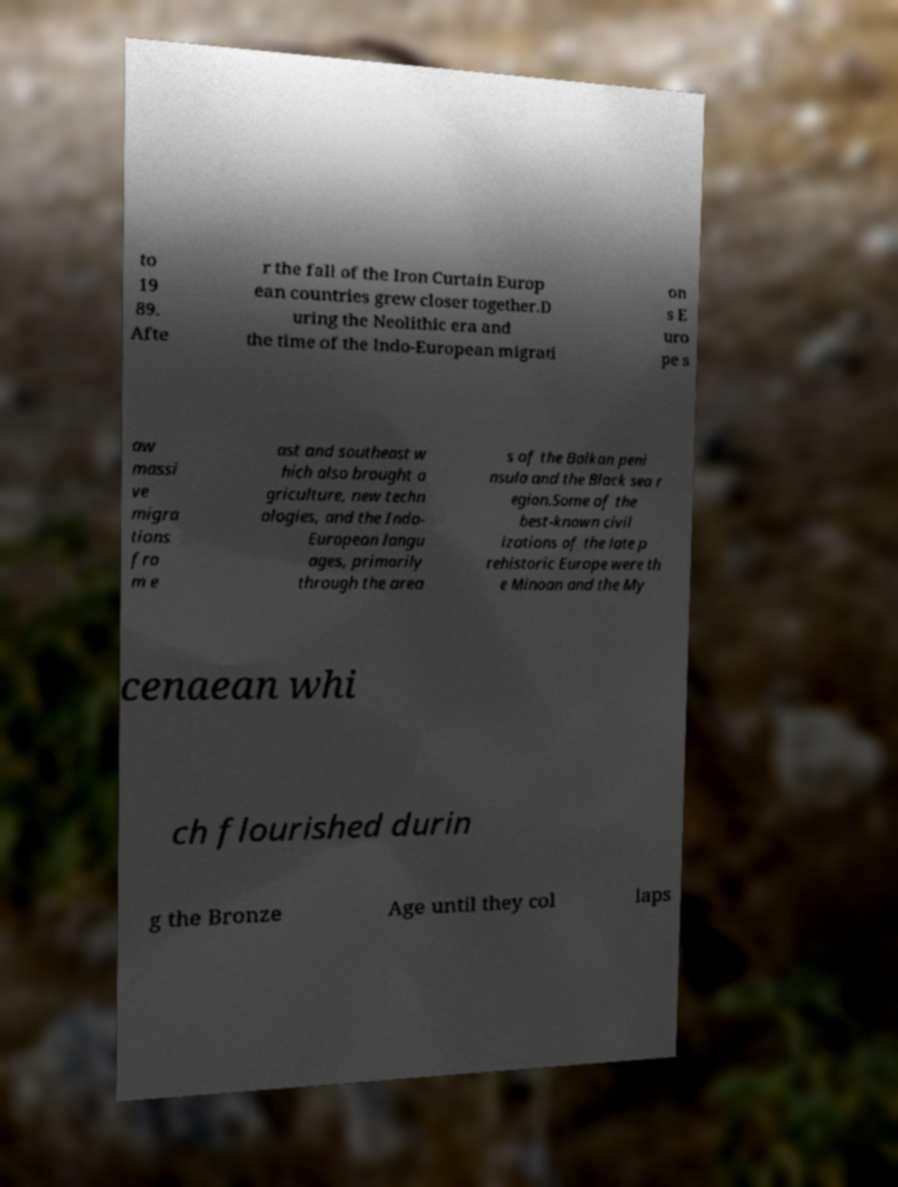Please identify and transcribe the text found in this image. to 19 89. Afte r the fall of the Iron Curtain Europ ean countries grew closer together.D uring the Neolithic era and the time of the Indo-European migrati on s E uro pe s aw massi ve migra tions fro m e ast and southeast w hich also brought a griculture, new techn ologies, and the Indo- European langu ages, primarily through the area s of the Balkan peni nsula and the Black sea r egion.Some of the best-known civil izations of the late p rehistoric Europe were th e Minoan and the My cenaean whi ch flourished durin g the Bronze Age until they col laps 